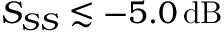<formula> <loc_0><loc_0><loc_500><loc_500>S _ { S S } \lesssim - 5 . 0 \, d B</formula> 